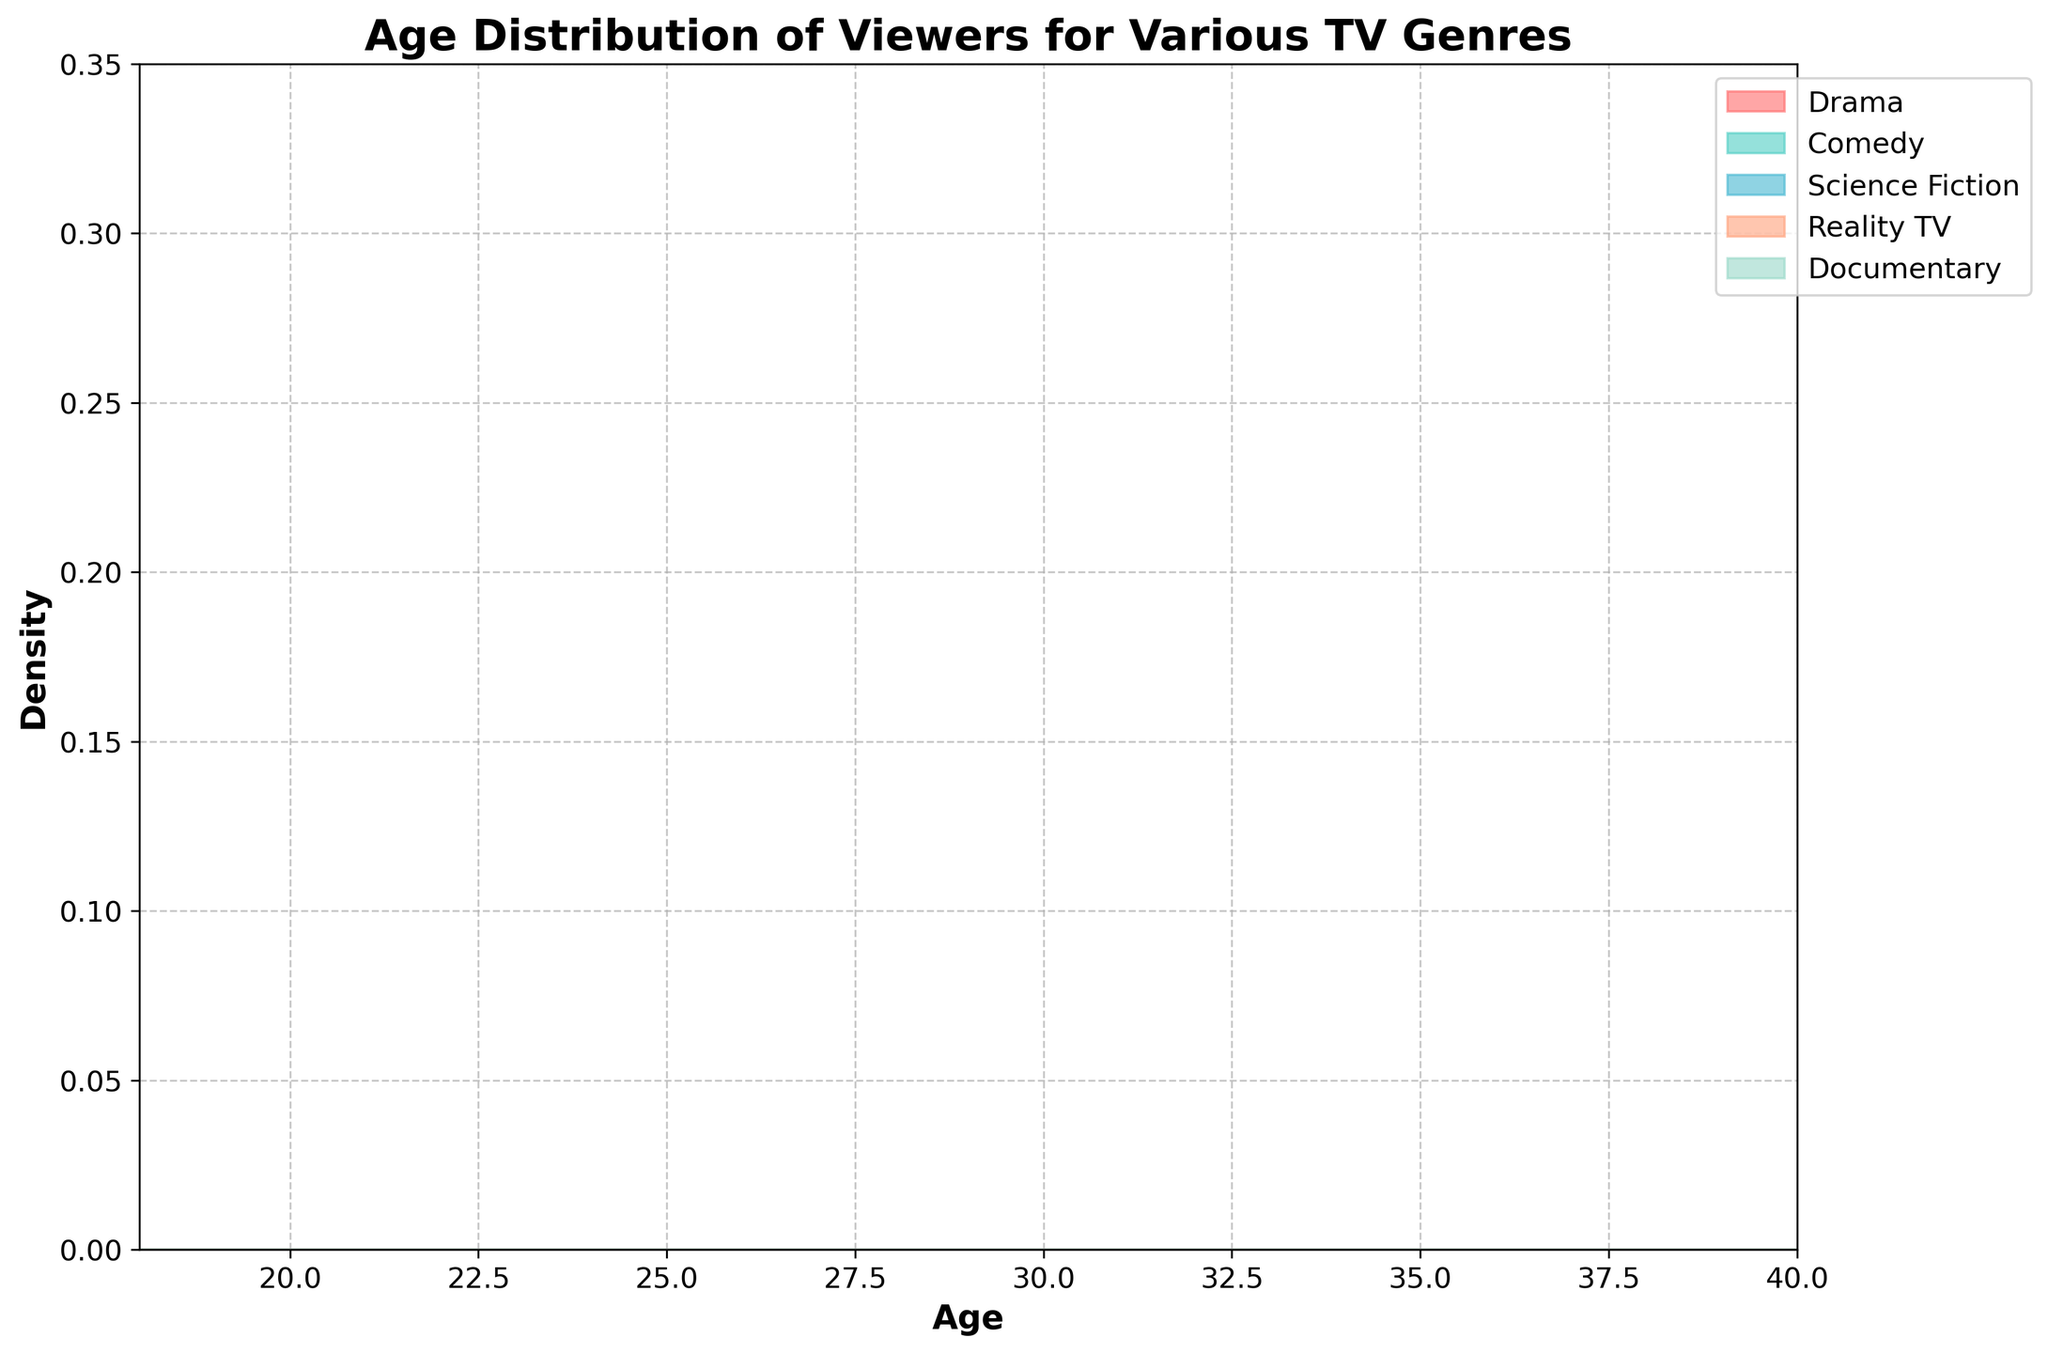What's the title of the figure? The title is prominently displayed at the top of the figure.
Answer: Age Distribution of Viewers for Various TV Genres What is the x-axis representing? The x-axis represents the age of the viewers, as marked at the bottom of the chart.
Answer: Age What genre has the densest viewer distribution around age 20? To determine this, observe the peaks of the density curves near age 20. The highest peak around this age should indicate the genre with the densest viewer distribution.
Answer: Science Fiction Which genre shows a peak density towards the later ages, close to 40? Observe the density curves towards the higher end of the age spectrum. The genres with peaks near age 40 will indicate their viewer density.
Answer: Comedy How does the viewer distribution for Science Fiction compare between ages 18 and 25? Look at the density curve for Science Fiction between ages 18 and 25. Compare the heights (which represent density) across this range.
Answer: Density decreases from age 18 to 25 What genre has the broadest age distribution? The broadest curve likely indicates the genre that appeals to a wider age range. Identify which of the colored curves spans the most age values.
Answer: Drama At which age is the density of Reality TV viewers the highest, and what is the approximate density value? Identify the peak of the Reality TV density curve and note the age and the height at this peak.
Answer: Age 26, ~0.20 How does the density of Documentary viewers change between ages 19 and 30? Examine the density curve for Documentaries within the age range from 19 to 30 and observe the changes in the height of the curve.
Answer: It increases, peaks near age 26, and then gradually decreases Which genre's viewer distribution shows a decline after age 35? Examine the curves after age 35 and identify which genre's density decreases.
Answer: Science Fiction Comparing Comedy and Reality TV, which genre has a higher viewer density at age 32? Look at the heights of the density curves for both Comedy and Reality TV at age 32, and compare.
Answer: Comedy 